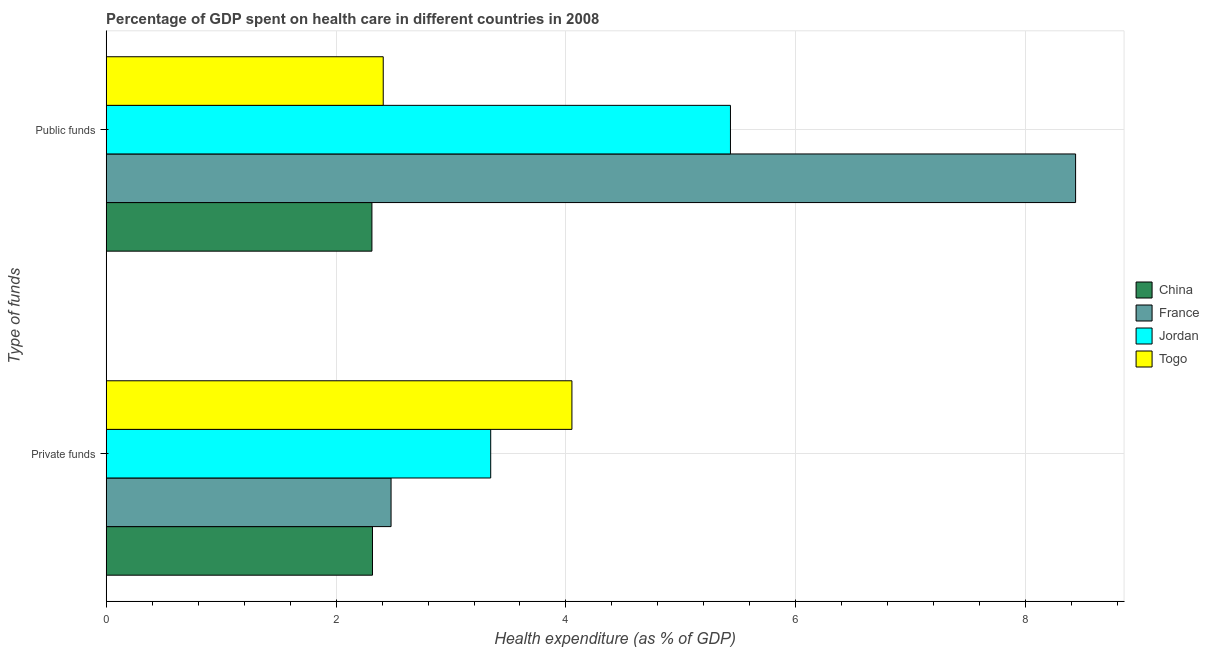How many different coloured bars are there?
Offer a very short reply. 4. How many bars are there on the 2nd tick from the bottom?
Provide a short and direct response. 4. What is the label of the 1st group of bars from the top?
Make the answer very short. Public funds. What is the amount of private funds spent in healthcare in China?
Your response must be concise. 2.32. Across all countries, what is the maximum amount of private funds spent in healthcare?
Offer a terse response. 4.05. Across all countries, what is the minimum amount of public funds spent in healthcare?
Provide a short and direct response. 2.31. In which country was the amount of public funds spent in healthcare maximum?
Your answer should be compact. France. What is the total amount of public funds spent in healthcare in the graph?
Your answer should be compact. 18.59. What is the difference between the amount of private funds spent in healthcare in China and that in Jordan?
Your answer should be very brief. -1.03. What is the difference between the amount of public funds spent in healthcare in China and the amount of private funds spent in healthcare in Jordan?
Ensure brevity in your answer.  -1.03. What is the average amount of private funds spent in healthcare per country?
Your answer should be very brief. 3.05. What is the difference between the amount of public funds spent in healthcare and amount of private funds spent in healthcare in China?
Provide a succinct answer. -0. In how many countries, is the amount of private funds spent in healthcare greater than 4 %?
Your response must be concise. 1. What is the ratio of the amount of private funds spent in healthcare in France to that in Jordan?
Your answer should be very brief. 0.74. Is the amount of public funds spent in healthcare in China less than that in Jordan?
Give a very brief answer. Yes. In how many countries, is the amount of public funds spent in healthcare greater than the average amount of public funds spent in healthcare taken over all countries?
Offer a very short reply. 2. What does the 4th bar from the top in Public funds represents?
Make the answer very short. China. What does the 3rd bar from the bottom in Private funds represents?
Offer a terse response. Jordan. How many bars are there?
Keep it short and to the point. 8. Are all the bars in the graph horizontal?
Make the answer very short. Yes. How many countries are there in the graph?
Keep it short and to the point. 4. Does the graph contain any zero values?
Provide a succinct answer. No. Does the graph contain grids?
Your response must be concise. Yes. How are the legend labels stacked?
Offer a terse response. Vertical. What is the title of the graph?
Offer a terse response. Percentage of GDP spent on health care in different countries in 2008. Does "Philippines" appear as one of the legend labels in the graph?
Provide a succinct answer. No. What is the label or title of the X-axis?
Give a very brief answer. Health expenditure (as % of GDP). What is the label or title of the Y-axis?
Keep it short and to the point. Type of funds. What is the Health expenditure (as % of GDP) in China in Private funds?
Offer a terse response. 2.32. What is the Health expenditure (as % of GDP) of France in Private funds?
Your answer should be compact. 2.48. What is the Health expenditure (as % of GDP) of Jordan in Private funds?
Provide a succinct answer. 3.35. What is the Health expenditure (as % of GDP) of Togo in Private funds?
Your answer should be compact. 4.05. What is the Health expenditure (as % of GDP) of China in Public funds?
Provide a short and direct response. 2.31. What is the Health expenditure (as % of GDP) in France in Public funds?
Your response must be concise. 8.43. What is the Health expenditure (as % of GDP) of Jordan in Public funds?
Offer a terse response. 5.43. What is the Health expenditure (as % of GDP) of Togo in Public funds?
Make the answer very short. 2.41. Across all Type of funds, what is the maximum Health expenditure (as % of GDP) in China?
Provide a succinct answer. 2.32. Across all Type of funds, what is the maximum Health expenditure (as % of GDP) in France?
Keep it short and to the point. 8.43. Across all Type of funds, what is the maximum Health expenditure (as % of GDP) of Jordan?
Keep it short and to the point. 5.43. Across all Type of funds, what is the maximum Health expenditure (as % of GDP) of Togo?
Offer a terse response. 4.05. Across all Type of funds, what is the minimum Health expenditure (as % of GDP) in China?
Your answer should be compact. 2.31. Across all Type of funds, what is the minimum Health expenditure (as % of GDP) of France?
Ensure brevity in your answer.  2.48. Across all Type of funds, what is the minimum Health expenditure (as % of GDP) of Jordan?
Provide a short and direct response. 3.35. Across all Type of funds, what is the minimum Health expenditure (as % of GDP) in Togo?
Provide a short and direct response. 2.41. What is the total Health expenditure (as % of GDP) in China in the graph?
Offer a terse response. 4.63. What is the total Health expenditure (as % of GDP) of France in the graph?
Provide a short and direct response. 10.91. What is the total Health expenditure (as % of GDP) of Jordan in the graph?
Keep it short and to the point. 8.78. What is the total Health expenditure (as % of GDP) in Togo in the graph?
Offer a very short reply. 6.46. What is the difference between the Health expenditure (as % of GDP) of China in Private funds and that in Public funds?
Provide a short and direct response. 0. What is the difference between the Health expenditure (as % of GDP) of France in Private funds and that in Public funds?
Ensure brevity in your answer.  -5.96. What is the difference between the Health expenditure (as % of GDP) in Jordan in Private funds and that in Public funds?
Your response must be concise. -2.09. What is the difference between the Health expenditure (as % of GDP) of Togo in Private funds and that in Public funds?
Offer a terse response. 1.64. What is the difference between the Health expenditure (as % of GDP) of China in Private funds and the Health expenditure (as % of GDP) of France in Public funds?
Provide a succinct answer. -6.12. What is the difference between the Health expenditure (as % of GDP) in China in Private funds and the Health expenditure (as % of GDP) in Jordan in Public funds?
Make the answer very short. -3.11. What is the difference between the Health expenditure (as % of GDP) of China in Private funds and the Health expenditure (as % of GDP) of Togo in Public funds?
Your response must be concise. -0.09. What is the difference between the Health expenditure (as % of GDP) in France in Private funds and the Health expenditure (as % of GDP) in Jordan in Public funds?
Ensure brevity in your answer.  -2.95. What is the difference between the Health expenditure (as % of GDP) in France in Private funds and the Health expenditure (as % of GDP) in Togo in Public funds?
Offer a very short reply. 0.07. What is the difference between the Health expenditure (as % of GDP) in Jordan in Private funds and the Health expenditure (as % of GDP) in Togo in Public funds?
Give a very brief answer. 0.94. What is the average Health expenditure (as % of GDP) of China per Type of funds?
Provide a succinct answer. 2.31. What is the average Health expenditure (as % of GDP) of France per Type of funds?
Provide a succinct answer. 5.46. What is the average Health expenditure (as % of GDP) in Jordan per Type of funds?
Offer a very short reply. 4.39. What is the average Health expenditure (as % of GDP) in Togo per Type of funds?
Ensure brevity in your answer.  3.23. What is the difference between the Health expenditure (as % of GDP) of China and Health expenditure (as % of GDP) of France in Private funds?
Offer a terse response. -0.16. What is the difference between the Health expenditure (as % of GDP) of China and Health expenditure (as % of GDP) of Jordan in Private funds?
Ensure brevity in your answer.  -1.03. What is the difference between the Health expenditure (as % of GDP) of China and Health expenditure (as % of GDP) of Togo in Private funds?
Ensure brevity in your answer.  -1.74. What is the difference between the Health expenditure (as % of GDP) of France and Health expenditure (as % of GDP) of Jordan in Private funds?
Your response must be concise. -0.87. What is the difference between the Health expenditure (as % of GDP) in France and Health expenditure (as % of GDP) in Togo in Private funds?
Give a very brief answer. -1.57. What is the difference between the Health expenditure (as % of GDP) in Jordan and Health expenditure (as % of GDP) in Togo in Private funds?
Provide a succinct answer. -0.71. What is the difference between the Health expenditure (as % of GDP) in China and Health expenditure (as % of GDP) in France in Public funds?
Provide a short and direct response. -6.12. What is the difference between the Health expenditure (as % of GDP) of China and Health expenditure (as % of GDP) of Jordan in Public funds?
Offer a very short reply. -3.12. What is the difference between the Health expenditure (as % of GDP) in China and Health expenditure (as % of GDP) in Togo in Public funds?
Offer a very short reply. -0.1. What is the difference between the Health expenditure (as % of GDP) of France and Health expenditure (as % of GDP) of Jordan in Public funds?
Make the answer very short. 3. What is the difference between the Health expenditure (as % of GDP) of France and Health expenditure (as % of GDP) of Togo in Public funds?
Ensure brevity in your answer.  6.02. What is the difference between the Health expenditure (as % of GDP) of Jordan and Health expenditure (as % of GDP) of Togo in Public funds?
Offer a terse response. 3.02. What is the ratio of the Health expenditure (as % of GDP) of France in Private funds to that in Public funds?
Your answer should be compact. 0.29. What is the ratio of the Health expenditure (as % of GDP) of Jordan in Private funds to that in Public funds?
Ensure brevity in your answer.  0.62. What is the ratio of the Health expenditure (as % of GDP) in Togo in Private funds to that in Public funds?
Offer a terse response. 1.68. What is the difference between the highest and the second highest Health expenditure (as % of GDP) in China?
Provide a short and direct response. 0. What is the difference between the highest and the second highest Health expenditure (as % of GDP) in France?
Keep it short and to the point. 5.96. What is the difference between the highest and the second highest Health expenditure (as % of GDP) in Jordan?
Keep it short and to the point. 2.09. What is the difference between the highest and the second highest Health expenditure (as % of GDP) in Togo?
Your response must be concise. 1.64. What is the difference between the highest and the lowest Health expenditure (as % of GDP) of China?
Make the answer very short. 0. What is the difference between the highest and the lowest Health expenditure (as % of GDP) in France?
Make the answer very short. 5.96. What is the difference between the highest and the lowest Health expenditure (as % of GDP) of Jordan?
Offer a very short reply. 2.09. What is the difference between the highest and the lowest Health expenditure (as % of GDP) of Togo?
Your answer should be compact. 1.64. 